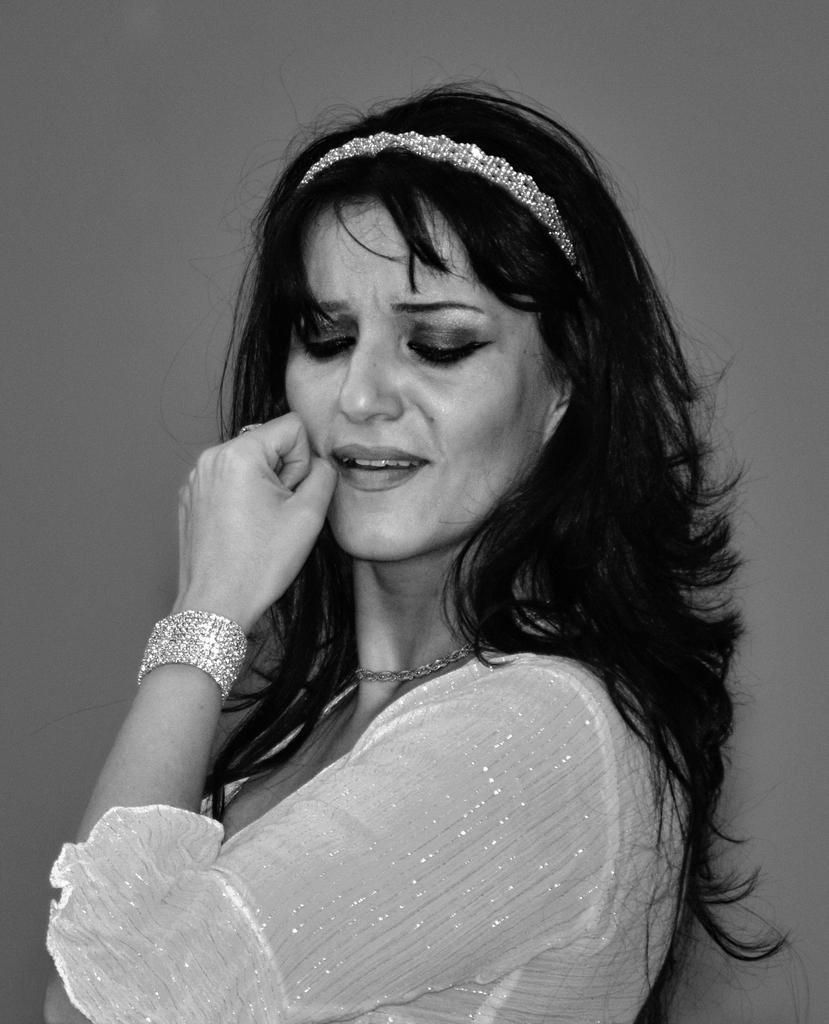Please provide a concise description of this image. In this edited image, we can see a person wearing clothes. 